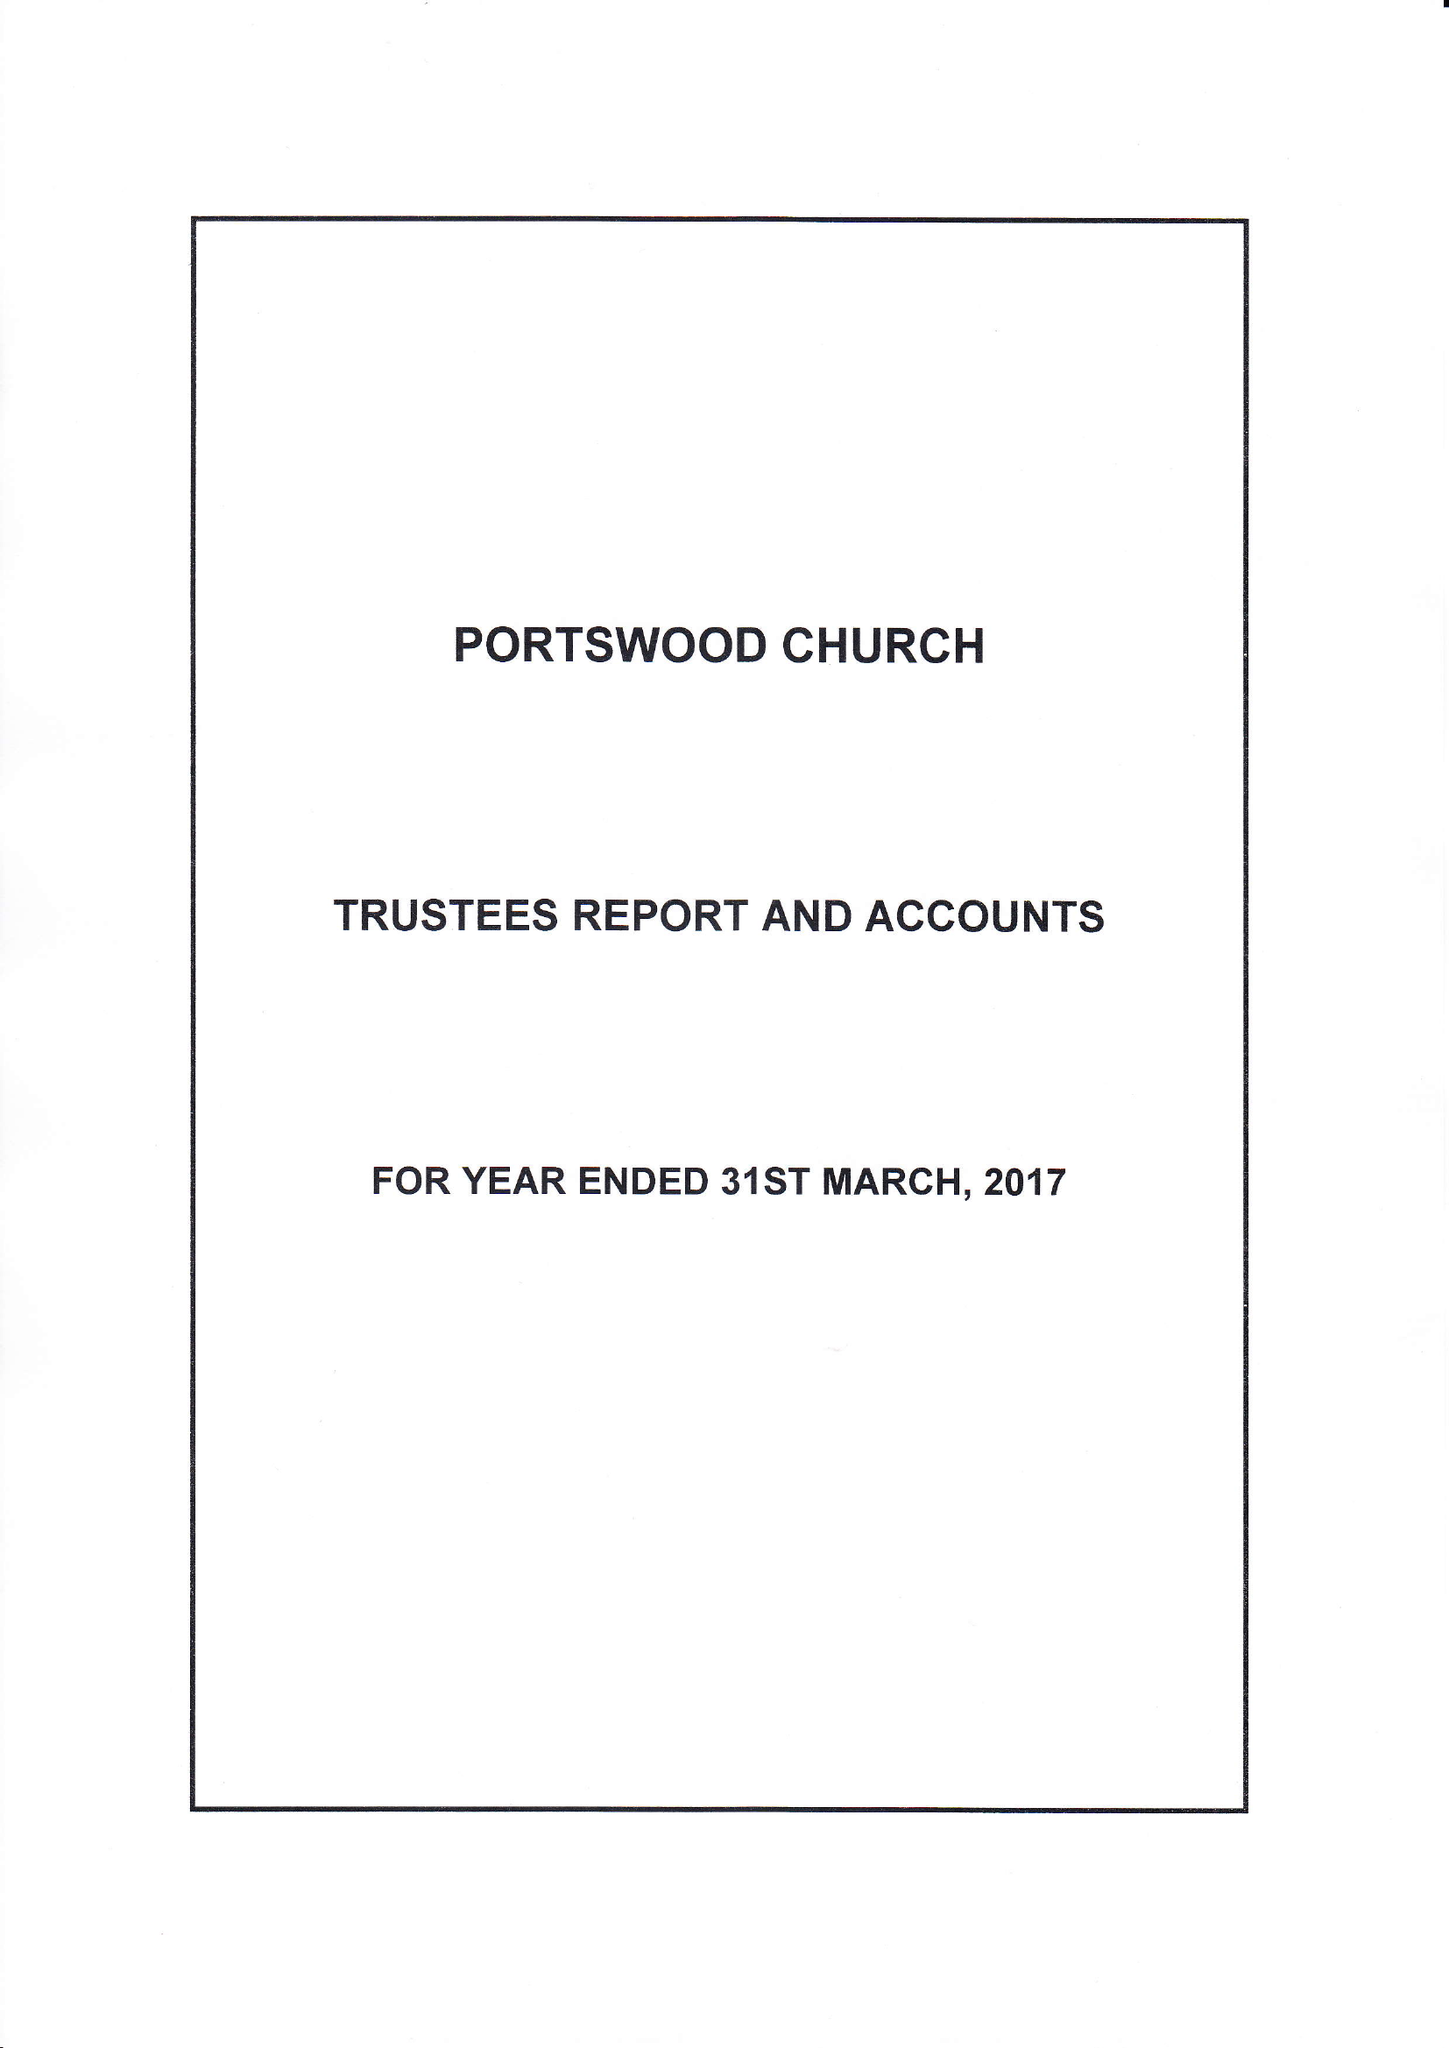What is the value for the report_date?
Answer the question using a single word or phrase. 2017-03-31 